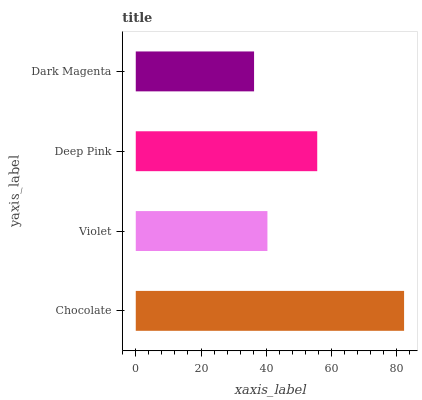Is Dark Magenta the minimum?
Answer yes or no. Yes. Is Chocolate the maximum?
Answer yes or no. Yes. Is Violet the minimum?
Answer yes or no. No. Is Violet the maximum?
Answer yes or no. No. Is Chocolate greater than Violet?
Answer yes or no. Yes. Is Violet less than Chocolate?
Answer yes or no. Yes. Is Violet greater than Chocolate?
Answer yes or no. No. Is Chocolate less than Violet?
Answer yes or no. No. Is Deep Pink the high median?
Answer yes or no. Yes. Is Violet the low median?
Answer yes or no. Yes. Is Chocolate the high median?
Answer yes or no. No. Is Chocolate the low median?
Answer yes or no. No. 